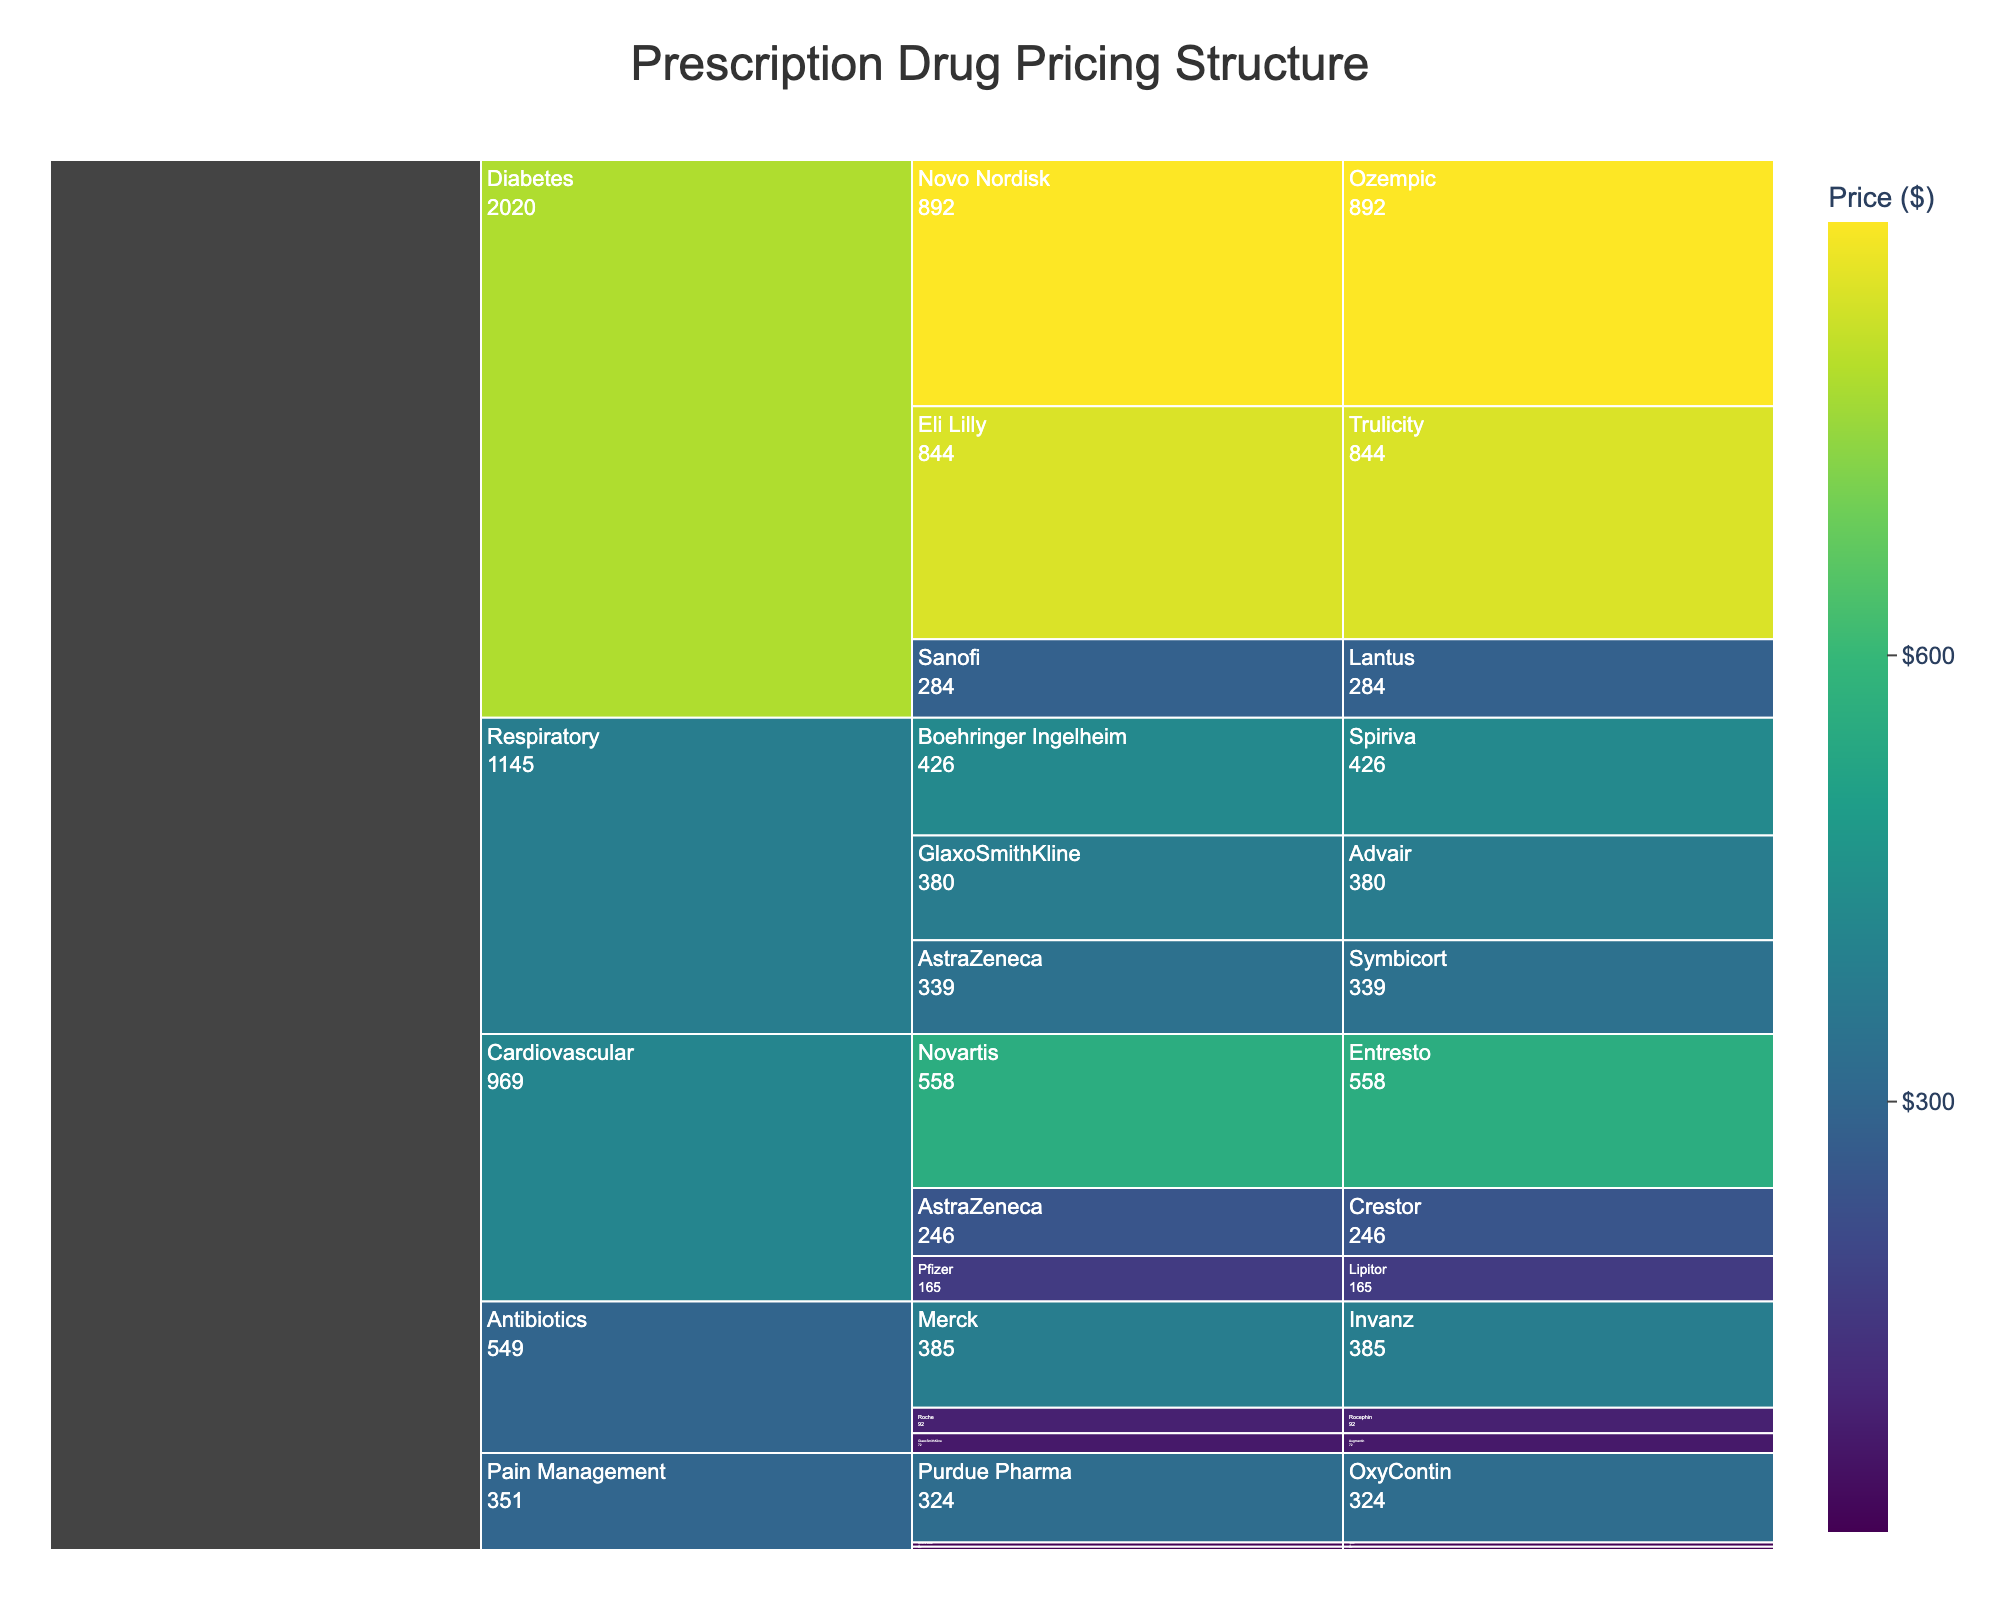How many drug classes are represented in the figure? There are sections in the Icicle Chart representing each drug class. Counting these sections gives us the total number of drug classes.
Answer: 5 Which manufacturer offers the most expensive cardiovascular drug? Look for the drug class "Cardiovascular," then identify the manufacturer with the highest price. Pfizer (Lipitor $165), AstraZeneca (Crestor $246), and Novartis (Entresto $558). The most expensive is Entresto by Novartis at $558.
Answer: Novartis What's the total price of the drugs in the Pain Management class? Sum the prices shown for the Pain Management drugs: Tylenol ($15), Aleve ($12), and OxyContin ($324). Calculate 15 + 12 + 324.
Answer: $351 Which drug class has the highest overall price when summed across all drugs? Sum the prices of all drugs within each class and then compare these sums. Cardiovascular: $969, Antibiotics: $549, Diabetes: $2020, Pain Management: $351, Respiratory: $1145. The highest total is in the Diabetes class.
Answer: Diabetes Is there any drug in the Diabetes class that costs less than $500? Examine the prices listed under the Diabetes class: Ozempic ($892), Trulicity ($844), and Lantus ($284). Lantus is priced below $500.
Answer: Yes Which has a higher total price: drugs under Respiratory class or Cardiovascular class? Sum the prices of all drugs in each class then compare the totals. Respiratory: Advair ($380) + Symbicort ($339) + Spiriva ($426) = $1145. Cardiovascular: Lipitor ($165) + Crestor ($246) + Entresto ($558) = $969. Respiratory has a higher total price.
Answer: Respiratory Which manufacturer provides the cheapest drug listed in the data? Identify the manufacturer with the lowest price among all drugs. The prices are Tylenol ($15) by Johnson & Johnson and Aleve ($12) by Bayer. Bayer’s Aleve is the cheapest at $12.
Answer: Bayer What’s the price difference between the most expensive and the least expensive drug in the Diabetes class? Identify the highest and lowest prices in the Diabetes class: Ozempic ($892) and Lantus ($284). Calculate the difference: 892 - 284.
Answer: $608 How do the prices of GlaxoSmithKline drugs compare across different classes? Compare the prices of drugs by GlaxoSmithKline in different classes. Augmentin in Antibiotics ($72) and Advair in Respiratory ($380). Advair is considerably more expensive than Augmentin.
Answer: Advair is more expensive Which class has the widest range of drug prices? Calculate the range (price difference between highest and lowest drug) for each class: Cardiovascular: $558-$165=$393, Antibiotics: $385-$72=$313, Diabetes: $892-$284=$608, Pain Management: $324-$12=$312, Respiratory: $426-$339=$87. The Diabetes class has the widest range at $608.
Answer: Diabetes 